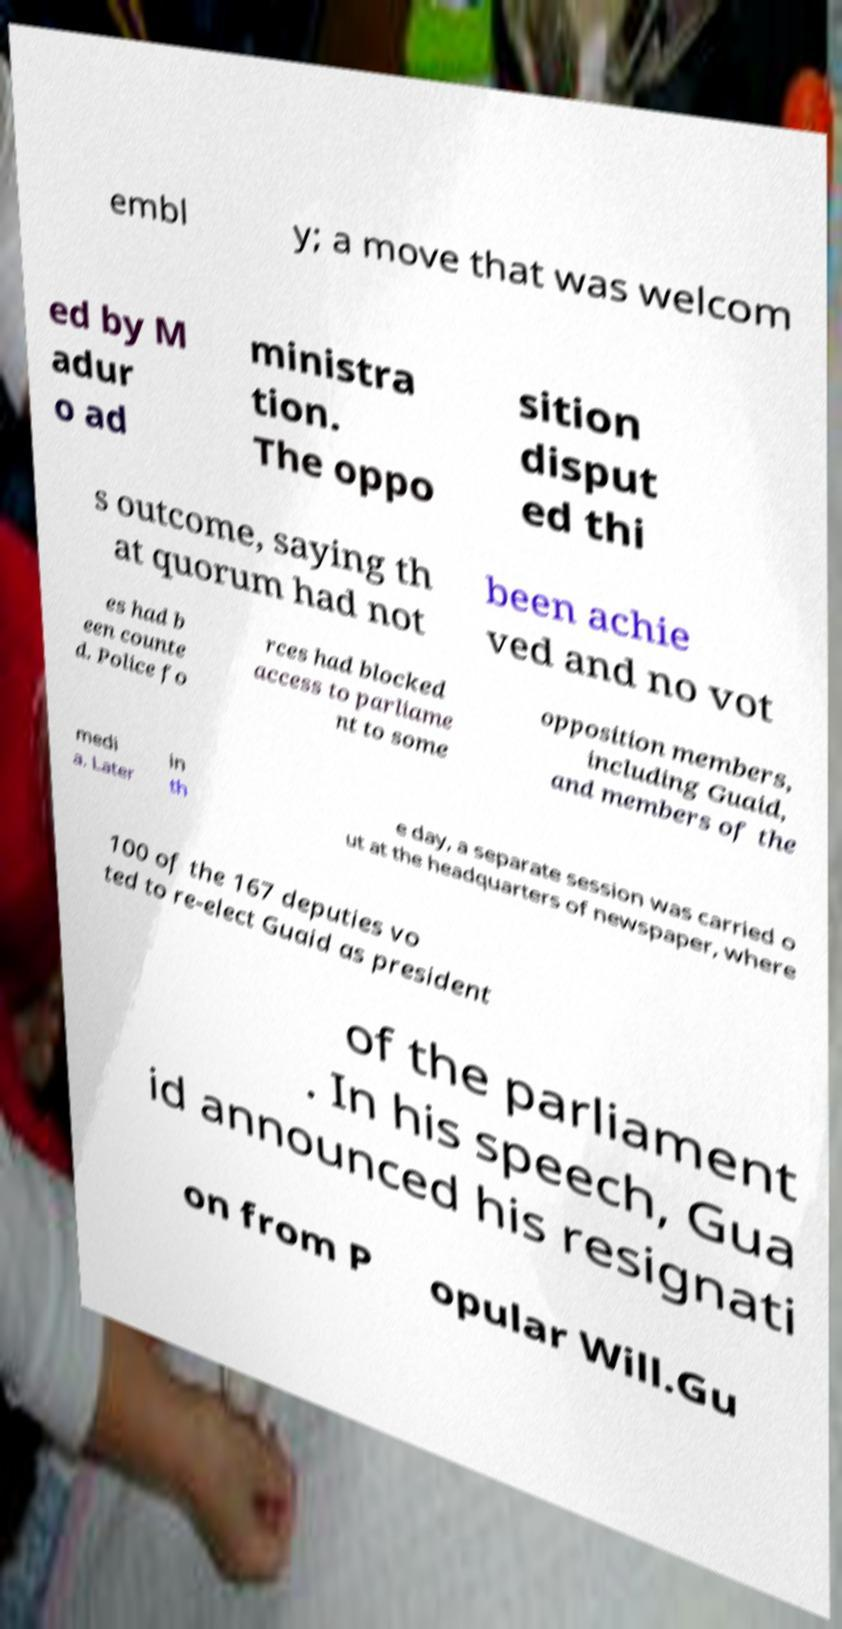There's text embedded in this image that I need extracted. Can you transcribe it verbatim? embl y; a move that was welcom ed by M adur o ad ministra tion. The oppo sition disput ed thi s outcome, saying th at quorum had not been achie ved and no vot es had b een counte d. Police fo rces had blocked access to parliame nt to some opposition members, including Guaid, and members of the medi a. Later in th e day, a separate session was carried o ut at the headquarters of newspaper, where 100 of the 167 deputies vo ted to re-elect Guaid as president of the parliament . In his speech, Gua id announced his resignati on from P opular Will.Gu 